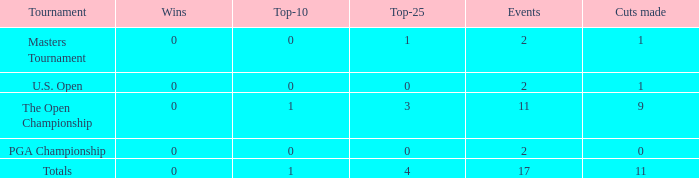How many wins did he have when he played under 2 events? 0.0. 